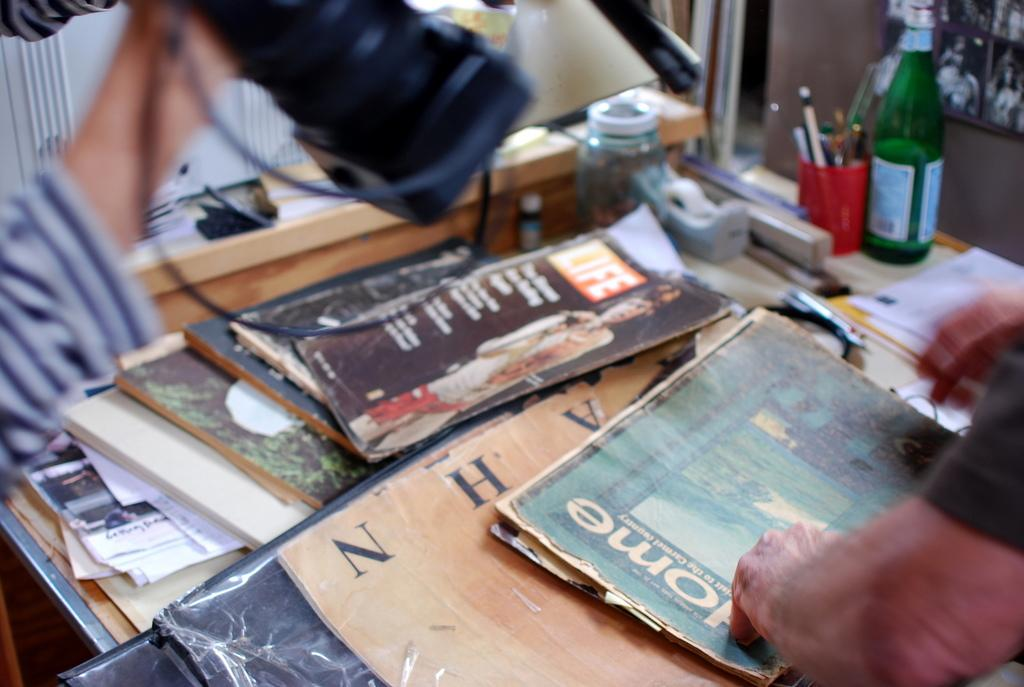<image>
Share a concise interpretation of the image provided. Several old magazines with a man's hand beside the word home. 